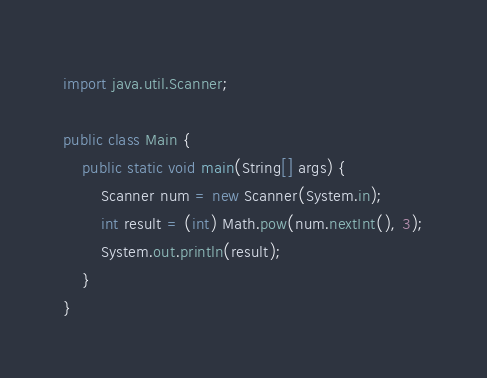Convert code to text. <code><loc_0><loc_0><loc_500><loc_500><_Java_>import java.util.Scanner;

public class Main {
    public static void main(String[] args) {
        Scanner num = new Scanner(System.in);
        int result = (int) Math.pow(num.nextInt(), 3);
        System.out.println(result);
    }
}
</code> 